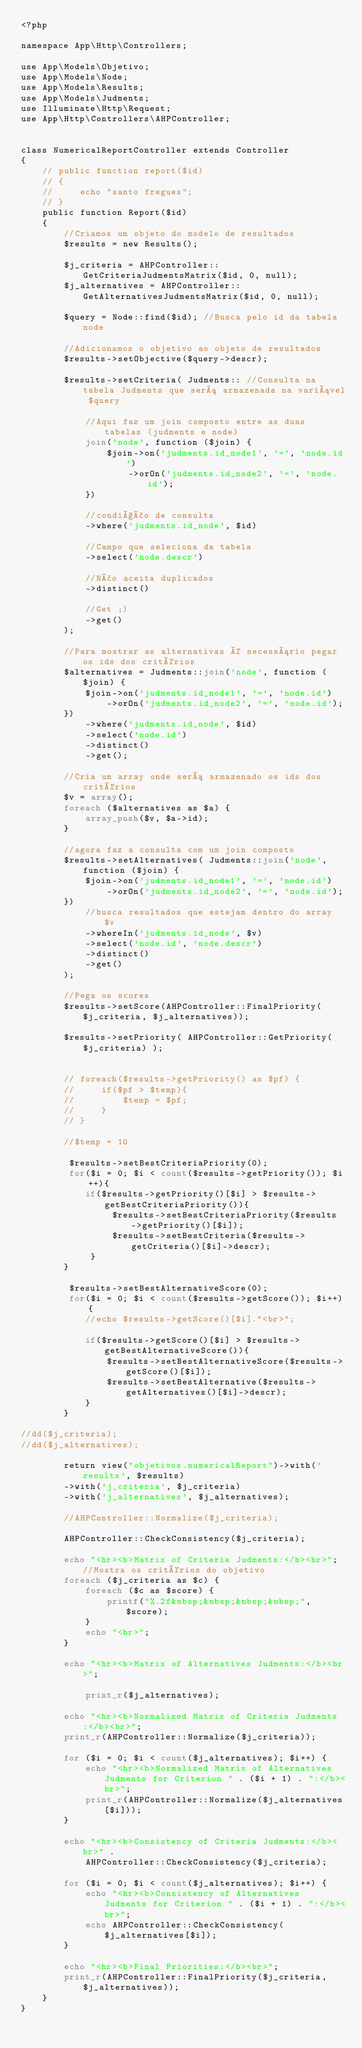<code> <loc_0><loc_0><loc_500><loc_500><_PHP_><?php

namespace App\Http\Controllers;

use App\Models\Objetivo;
use App\Models\Node;
use App\Models\Results;
use App\Models\Judments;
use Illuminate\Http\Request;
use App\Http\Controllers\AHPController;


class NumericalReportController extends Controller
{
    // public function report($id)
    // {
    //     echo "santo fregues";
    // }
    public function Report($id)
    {
        //Criamos um objeto do modelo de resultados 
        $results = new Results();

        $j_criteria = AHPController::GetCriteriaJudmentsMatrix($id, 0, null);
        $j_alternatives = AHPController::GetAlternativesJudmentsMatrix($id, 0, null);

        $query = Node::find($id); //Busca pelo id da tabela node
        
        //Adicionamos o objetivo ao objeto de resultados
        $results->setObjective($query->descr);

        $results->setCriteria( Judments:: //Consulta na tabela Judments que será armazenada na variável $query

            //Aqui faz um join composto entre as duas tabelas (judments e node)
            join('node', function ($join) {
                $join->on('judments.id_node1', '=', 'node.id')
                    ->orOn('judments.id_node2', '=', 'node.id');
            })

            //condição de consulta
            ->where('judments.id_node', $id)

            //Campo que seleciona da tabela
            ->select('node.descr')

            //Não aceita duplicados
            ->distinct()

            //Get ;)
            ->get()
        );

        //Para mostrar as alternativas é necessário pegar os ids dos critérios
        $alternatives = Judments::join('node', function ($join) {
            $join->on('judments.id_node1', '=', 'node.id')
                ->orOn('judments.id_node2', '=', 'node.id');
        })
            ->where('judments.id_node', $id)
            ->select('node.id')
            ->distinct()
            ->get();

        //Cria um array onde será armazenado os ids dos critérios
        $v = array();
        foreach ($alternatives as $a) {
            array_push($v, $a->id);
        }

        //agora faz a consulta com um join composto
        $results->setAlternatives( Judments::join('node', function ($join) {
            $join->on('judments.id_node1', '=', 'node.id')
                ->orOn('judments.id_node2', '=', 'node.id');
        })
            //busca resultados que estejam dentro do array $v
            ->whereIn('judments.id_node', $v)
            ->select('node.id', 'node.descr')
            ->distinct()
            ->get()
        );

        //Pega os scores
        $results->setScore(AHPController::FinalPriority($j_criteria, $j_alternatives));

        $results->setPriority( AHPController::GetPriority($j_criteria) );
        
        
        // foreach($results->getPriority() as $pf) {
        //     if($pf > $temp){
        //         $temp = $pf;
        //     }
        // }

        //$temp = 10

         $results->setBestCriteriaPriority(0);
         for($i = 0; $i < count($results->getPriority()); $i++){
            if($results->getPriority()[$i] > $results->getBestCriteriaPriority()){
                 $results->setBestCriteriaPriority($results->getPriority()[$i]);
                 $results->setBestCriteria($results->getCriteria()[$i]->descr);
             }    
        }

         $results->setBestAlternativeScore(0);
         for($i = 0; $i < count($results->getScore()); $i++){
            //echo $results->getScore()[$i]."<br>";

            if($results->getScore()[$i] > $results->getBestAlternativeScore()){
                $results->setBestAlternativeScore($results->getScore()[$i]);
                $results->setBestAlternative($results->getAlternatives()[$i]->descr);
            }    
        }

//dd($j_criteria);
//dd($j_alternatives);

        return view("objetivos.numericalReport")->with('results', $results)
        ->with('j_criteria', $j_criteria)
        ->with('j_alternatives', $j_alternatives);
     
        //AHPController::Normalize($j_criteria);
        
        AHPController::CheckConsistency($j_criteria);

        echo "<hr><b>Matrix of Criteria Judments:</b><br>"; //Mostra os critérios do objetivo
        foreach ($j_criteria as $c) {
            foreach ($c as $score) {
                printf("%.2f&nbsp;&nbsp;&nbsp;&nbsp;", $score);
            }
            echo "<br>";
        }
        
        echo "<hr><b>Matrix of Alternatives Judments:</b><br>";

            print_r($j_alternatives);

        echo "<hr><b>Normalized Matrix of Criteria Judments:</b><br>";
        print_r(AHPController::Normalize($j_criteria));

        for ($i = 0; $i < count($j_alternatives); $i++) {
            echo "<hr><b>Normalized Matrix of Alternatives Judments for Criterion " . ($i + 1) . ":</b><br>";
            print_r(AHPController::Normalize($j_alternatives[$i]));
        }

        echo "<hr><b>Consistency of Criteria Judments:</b><br>" .
            AHPController::CheckConsistency($j_criteria);

        for ($i = 0; $i < count($j_alternatives); $i++) {
            echo "<hr><b>Consistency of Alternatives Judments for Criterion " . ($i + 1) . ":</b><br>";
            echo AHPController::CheckConsistency($j_alternatives[$i]);
        }

        echo "<hr><b>Final Priorities:</b><br>";
        print_r(AHPController::FinalPriority($j_criteria, $j_alternatives));
    }
}</code> 